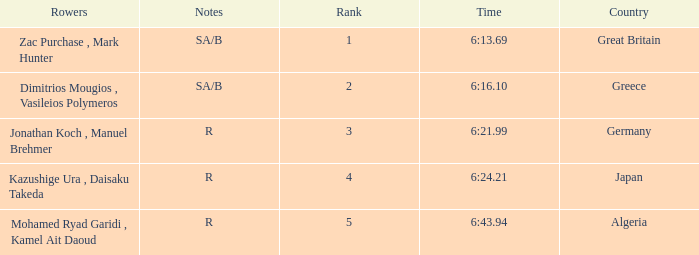What country is ranked #2? Greece. 